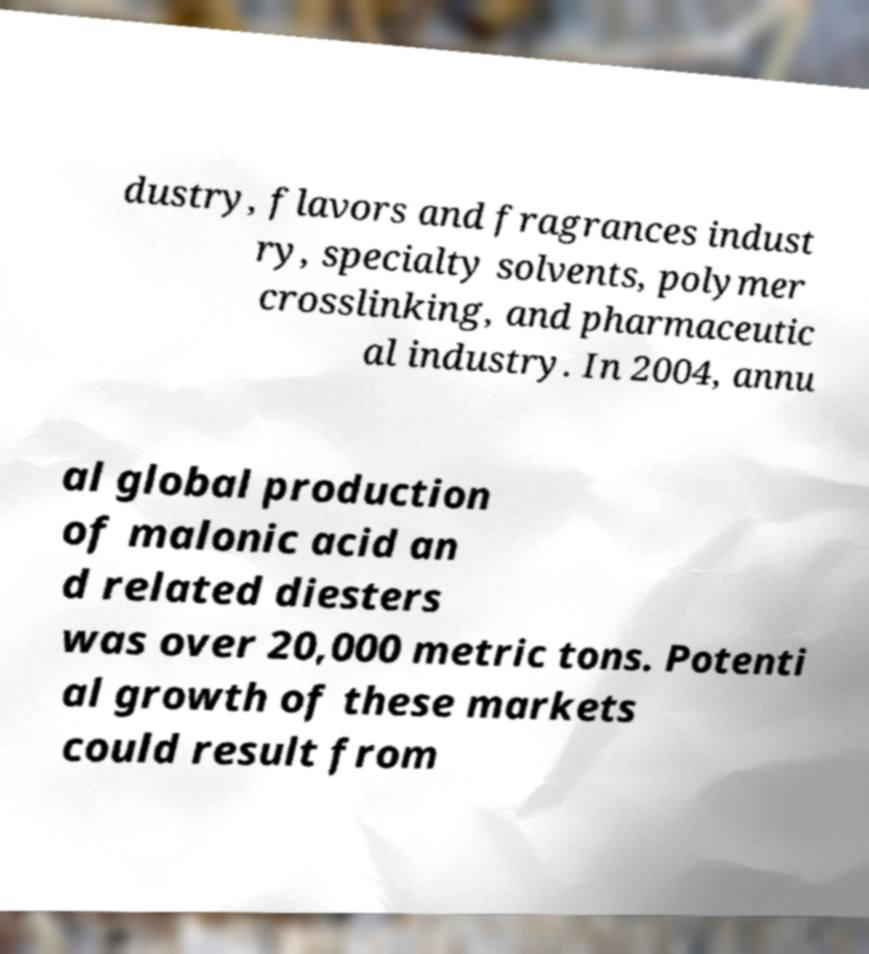Please identify and transcribe the text found in this image. dustry, flavors and fragrances indust ry, specialty solvents, polymer crosslinking, and pharmaceutic al industry. In 2004, annu al global production of malonic acid an d related diesters was over 20,000 metric tons. Potenti al growth of these markets could result from 